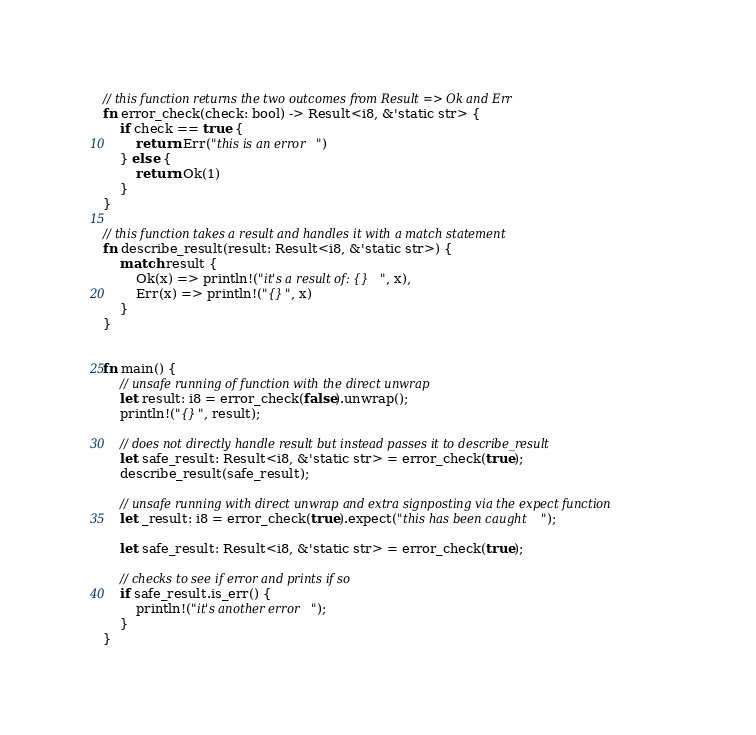Convert code to text. <code><loc_0><loc_0><loc_500><loc_500><_Rust_>// this function returns the two outcomes from Result => Ok and Err
fn error_check(check: bool) -> Result<i8, &'static str> {
    if check == true {
        return Err("this is an error")
    } else {
        return Ok(1)
    }
}

// this function takes a result and handles it with a match statement
fn describe_result(result: Result<i8, &'static str>) {
    match result {
        Ok(x) => println!("it's a result of: {}", x),
        Err(x) => println!("{}", x)
    }
}


fn main() {
    // unsafe running of function with the direct unwrap
    let result: i8 = error_check(false).unwrap();
    println!("{}", result);

    // does not directly handle result but instead passes it to describe_result
    let safe_result: Result<i8, &'static str> = error_check(true);
    describe_result(safe_result);

    // unsafe running with direct unwrap and extra signposting via the expect function
    let _result: i8 = error_check(true).expect("this has been caught");

    let safe_result: Result<i8, &'static str> = error_check(true);

    // checks to see if error and prints if so
    if safe_result.is_err() {
        println!("it's another error");
    }
}
</code> 